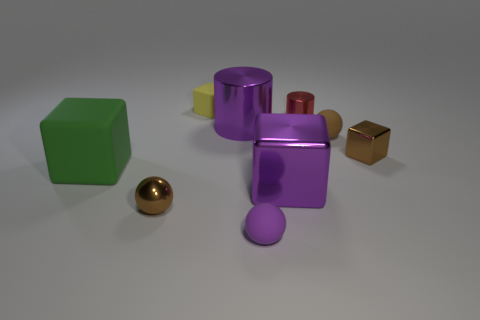Subtract all purple cylinders. Subtract all brown spheres. How many cylinders are left? 1 Subtract all cylinders. How many objects are left? 7 Subtract 0 cyan cubes. How many objects are left? 9 Subtract all large green rubber cylinders. Subtract all large green blocks. How many objects are left? 8 Add 4 green things. How many green things are left? 5 Add 7 rubber cubes. How many rubber cubes exist? 9 